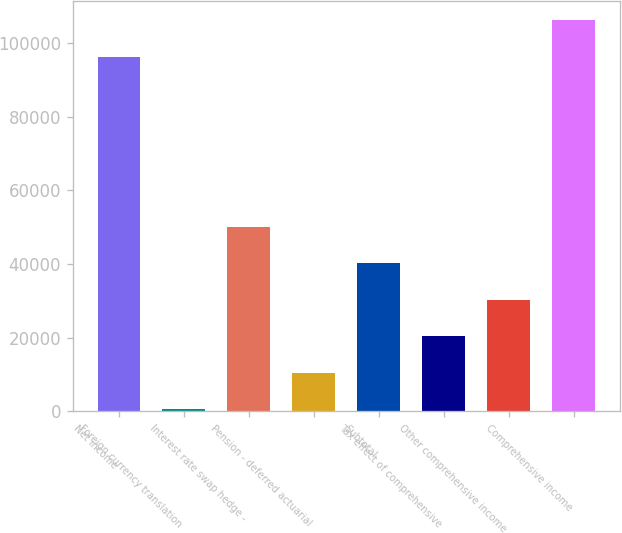<chart> <loc_0><loc_0><loc_500><loc_500><bar_chart><fcel>Net income<fcel>Foreign currency translation<fcel>Interest rate swap hedge -<fcel>Pension - deferred actuarial<fcel>Subtotal<fcel>Tax effect of comprehensive<fcel>Other comprehensive income<fcel>Comprehensive income<nl><fcel>96285<fcel>582<fcel>50091.5<fcel>10483.9<fcel>40189.6<fcel>20385.8<fcel>30287.7<fcel>106187<nl></chart> 